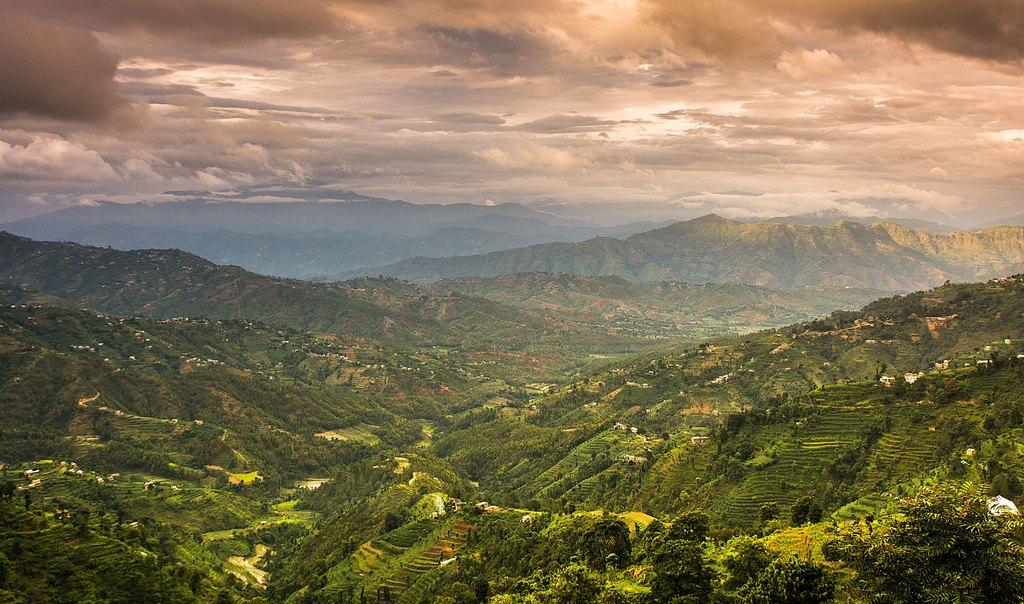What types of vegetation can be seen in the image? There are plants and trees in the image. What color are the plants and trees? The plants and trees are green in color. What can be seen in the distance in the image? There are mountains visible in the background of the image. What is the color of the sky in the image? The sky is white and gray in color. How many boats are visible in the image? There are no boats present in the image. Are there any babies playing with the plants in the image? There are no babies present in the image. 